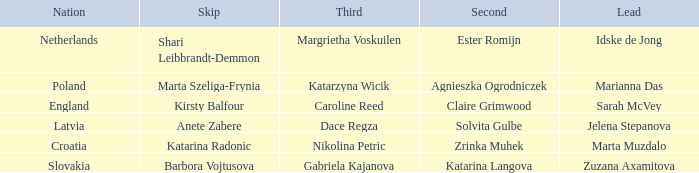What is the name of the second who has Caroline Reed as third? Claire Grimwood. 